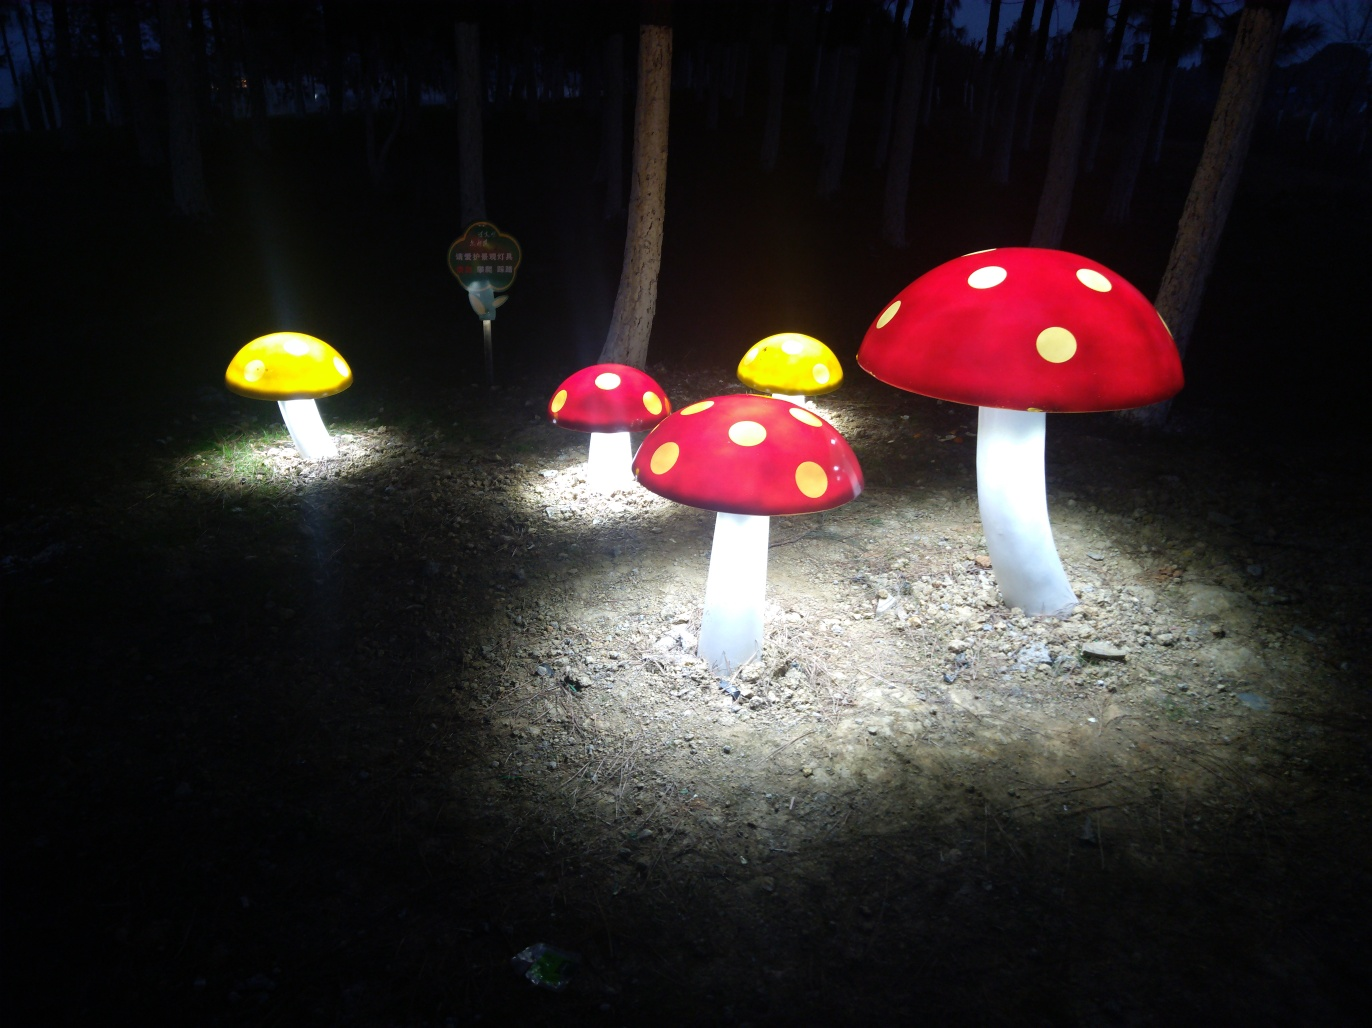What time of day does this picture seem to be taken? Given the darkness surrounding the illuminated mushrooms, it's likely that this photo was taken during the evening or at night. 